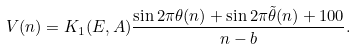<formula> <loc_0><loc_0><loc_500><loc_500>V ( n ) = K _ { 1 } ( E , A ) \frac { \sin 2 \pi \theta ( n ) + \sin 2 \pi \tilde { \theta } ( n ) + 1 0 0 } { n - b } .</formula> 